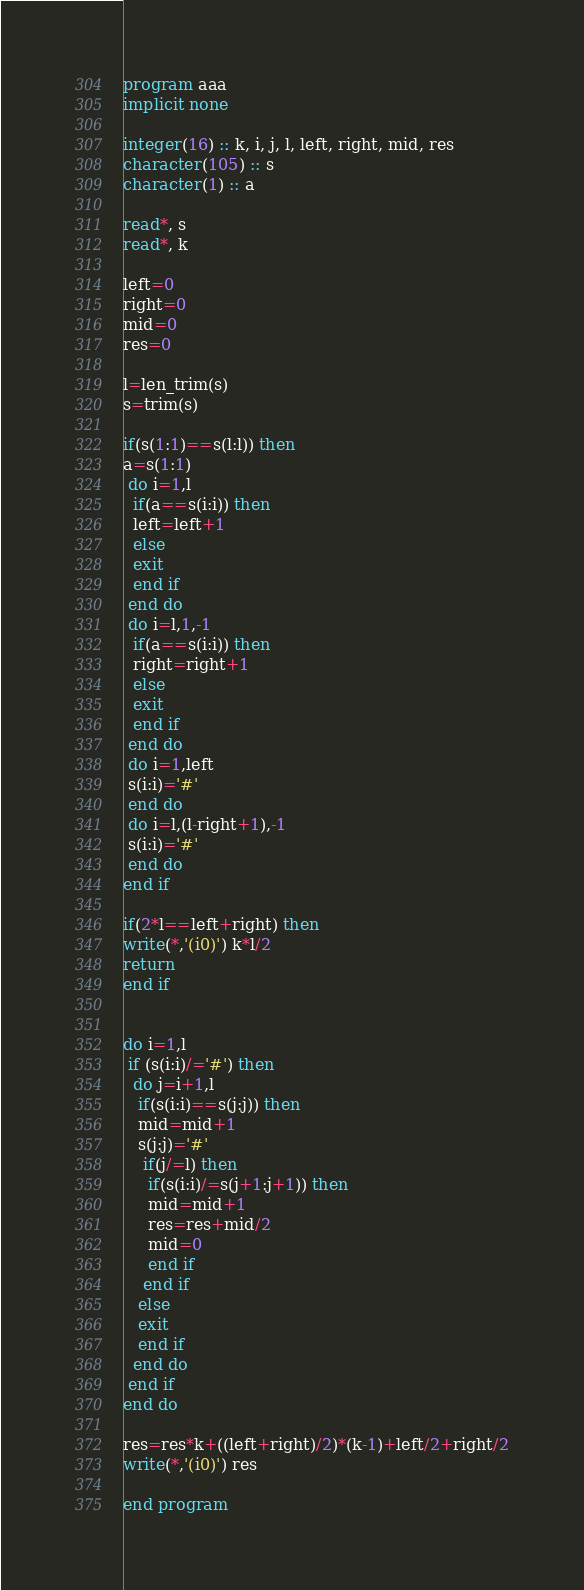Convert code to text. <code><loc_0><loc_0><loc_500><loc_500><_FORTRAN_>program aaa
implicit none

integer(16) :: k, i, j, l, left, right, mid, res
character(105) :: s
character(1) :: a

read*, s
read*, k

left=0
right=0
mid=0
res=0

l=len_trim(s)
s=trim(s)

if(s(1:1)==s(l:l)) then
a=s(1:1)
 do i=1,l
  if(a==s(i:i)) then
  left=left+1
  else
  exit
  end if
 end do
 do i=l,1,-1
  if(a==s(i:i)) then
  right=right+1
  else
  exit
  end if
 end do
 do i=1,left
 s(i:i)='#'
 end do
 do i=l,(l-right+1),-1
 s(i:i)='#'
 end do
end if

if(2*l==left+right) then
write(*,'(i0)') k*l/2
return
end if


do i=1,l
 if (s(i:i)/='#') then
  do j=i+1,l
   if(s(i:i)==s(j:j)) then
   mid=mid+1
   s(j:j)='#'
    if(j/=l) then
     if(s(i:i)/=s(j+1:j+1)) then
     mid=mid+1
     res=res+mid/2
     mid=0
     end if
    end if
   else
   exit
   end if
  end do
 end if
end do

res=res*k+((left+right)/2)*(k-1)+left/2+right/2
write(*,'(i0)') res

end program</code> 